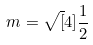Convert formula to latex. <formula><loc_0><loc_0><loc_500><loc_500>m = \sqrt { [ } 4 ] { \frac { 1 } { 2 } }</formula> 